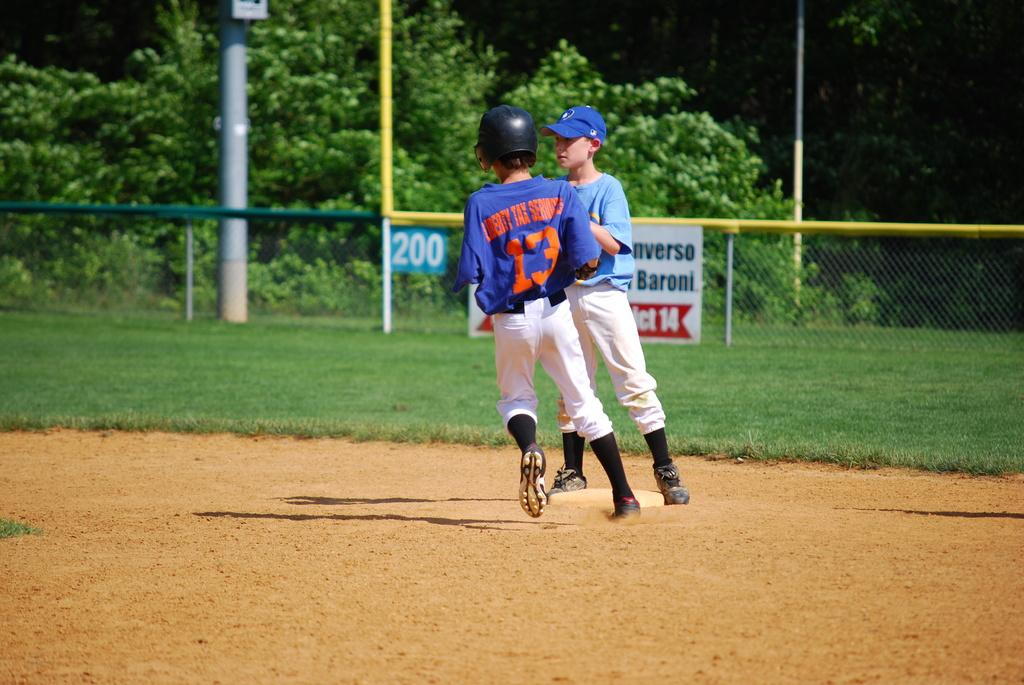<image>
Write a terse but informative summary of the picture. two children playnig baseball in liberty tax services uniform. 